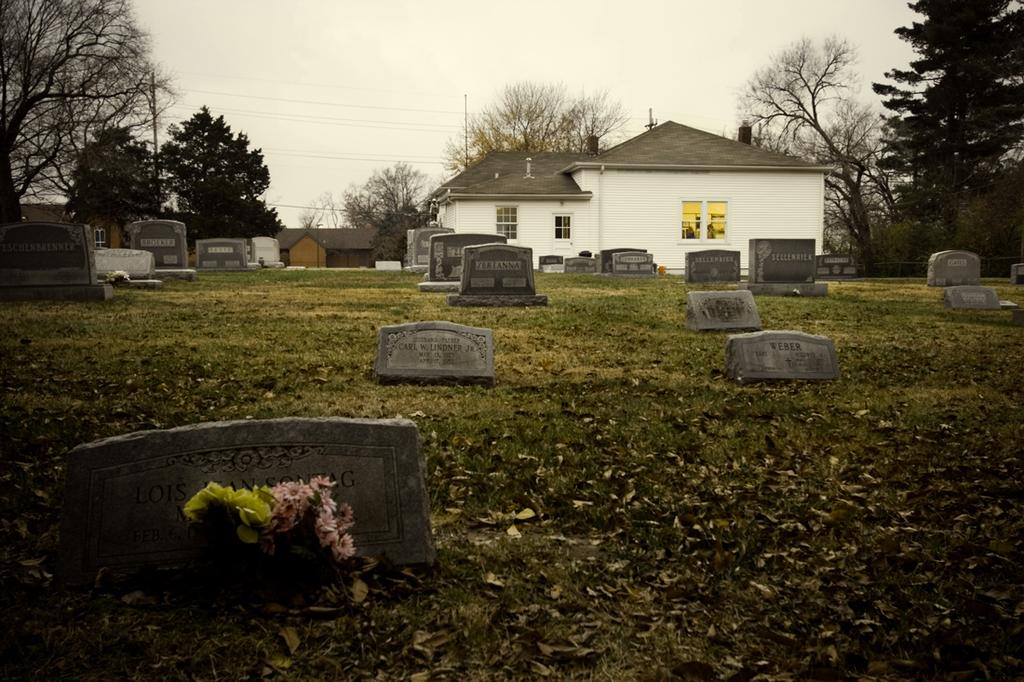What can be found at the bottom of the image? There are graves at the bottom of the image. What is placed near the graves? There are flowers near the graves. What is located in the background of the image? There is a shed and trees in the background of the image. What is visible at the top of the image? The sky is visible at the top of the image. What type of floor can be seen in the image? There is no floor visible in the image; it features graves, flowers, a shed, trees, and the sky. How does the image draw the viewer's attention to the graves? The image does not actively draw attention to the graves; it simply presents them as part of the scene. 